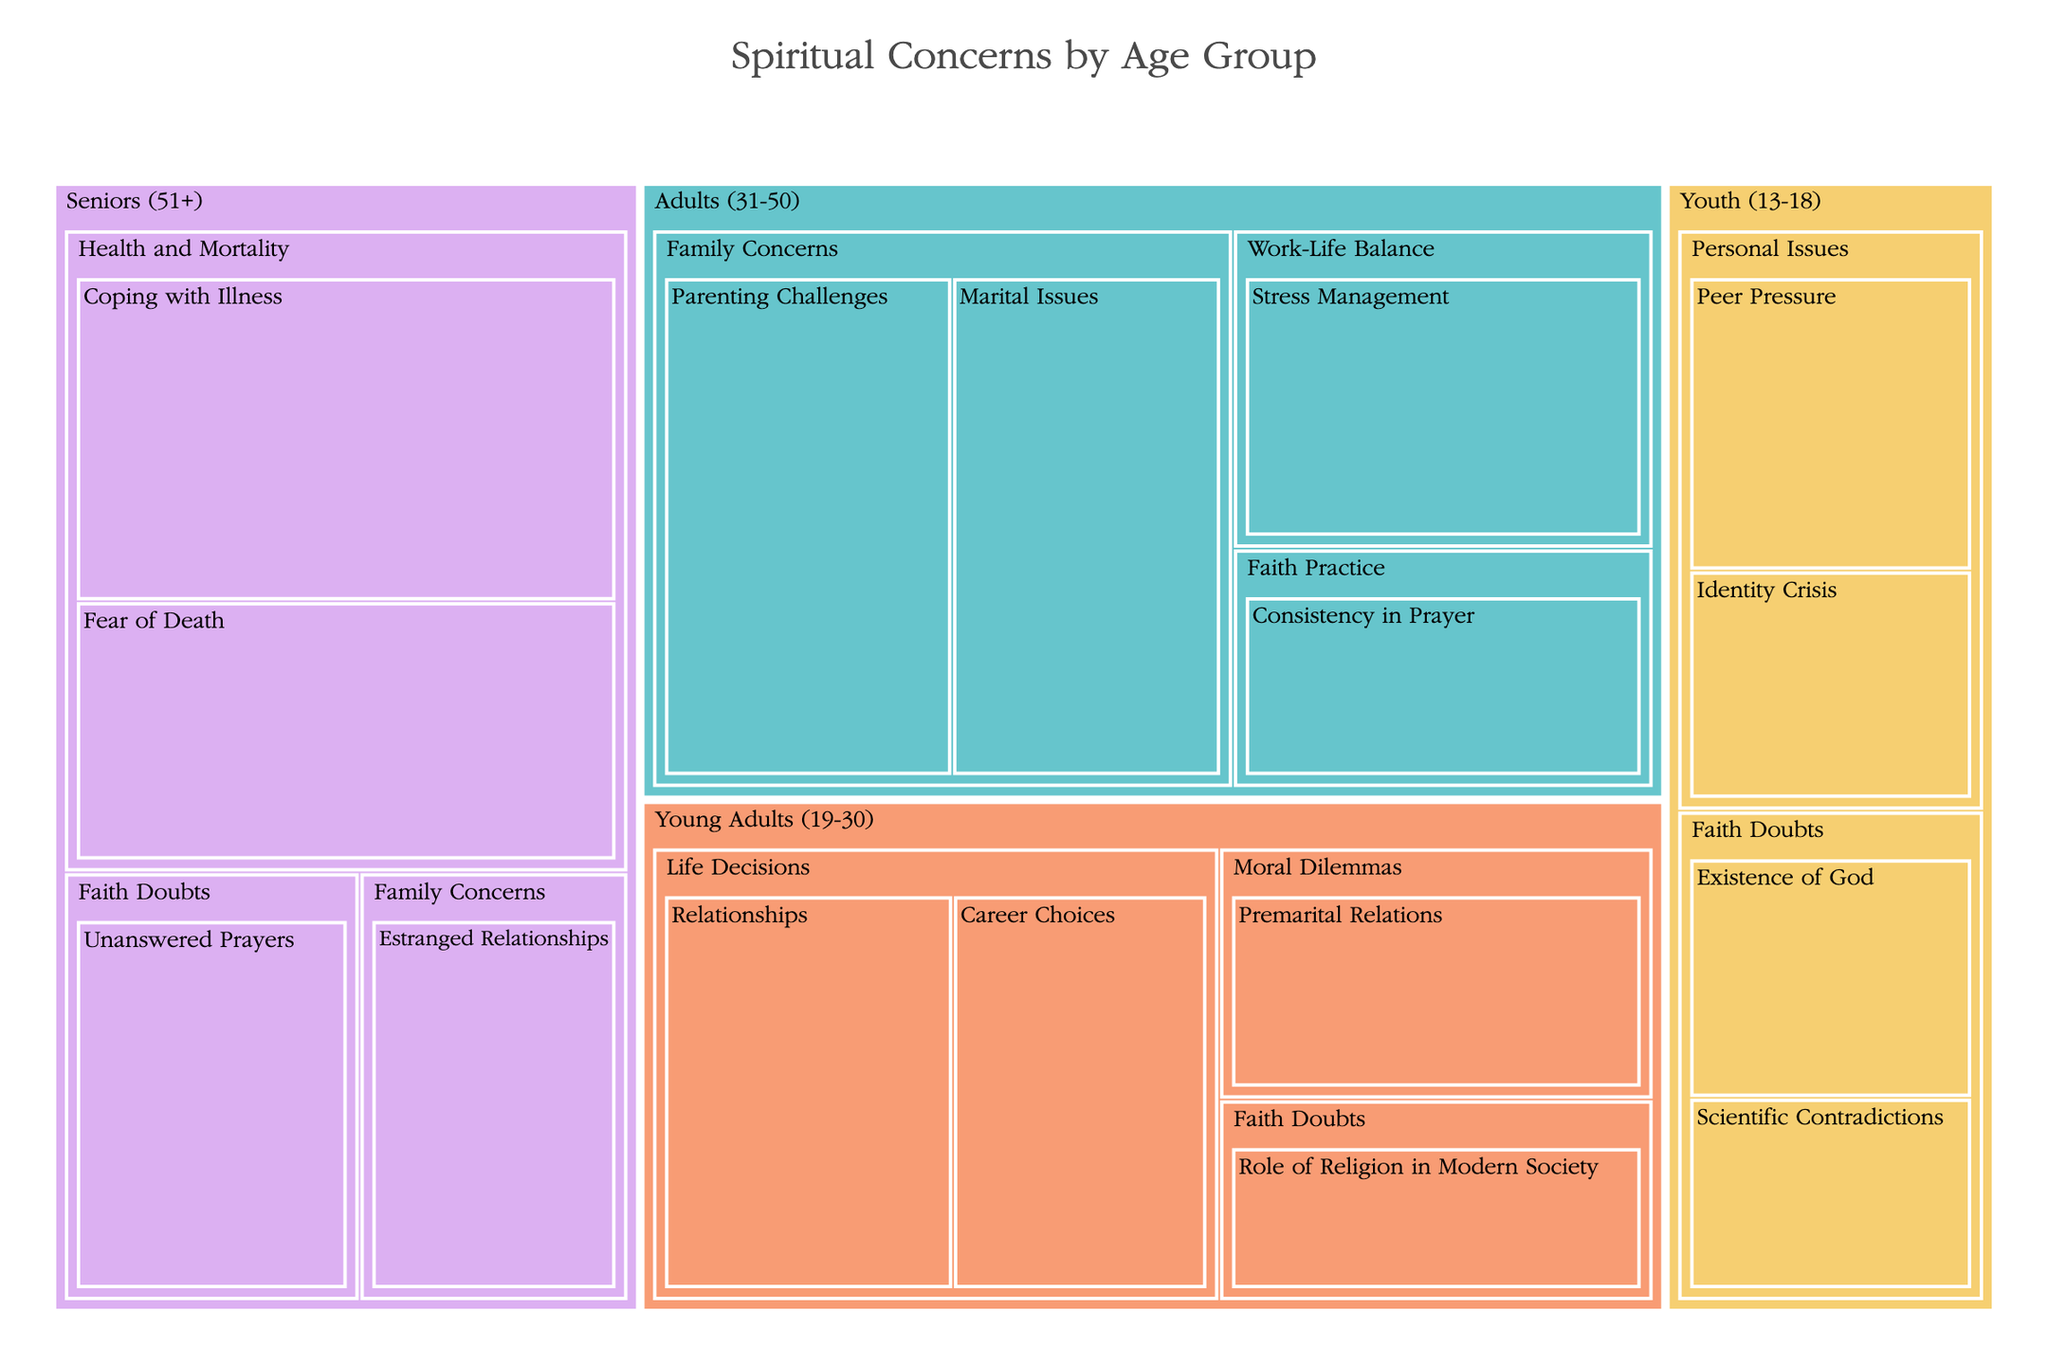What's the highest frequency of a specific concern for the Youth (13-18) age group? Observe the section labeled "Youth (13-18)" and identify the largest box within it. The "Peer Pressure" concern has the highest value with a frequency of 18.
Answer: Peer Pressure, 18 Which age group has the highest frequency concern related to "Health and Mortality"? Locate the "Health and Mortality" concern across different age groups. The "Coping with Illness" box for the Seniors (51+) group shows the highest frequency of 35.
Answer: Seniors (51+), Coping with Illness, 35 What is the total frequency of all concerns in the Adults (31-50) age group? Sum the frequencies of all concerns under the "Adults (31-50)" age group: Parenting Challenges (30), Marital Issues (28), Stress Management (24), and Consistency in Prayer (18). The total is 30 + 28 + 24 + 18 = 100.
Answer: 100 Compare the frequency of "Faith Doubts" concerns between Youth (13-18) and Seniors (51+). Which group has more frequency on this concern, and by how much? "Faith Doubts" concerns for Youth (13-18): Existence of God (15) + Scientific Contradictions (12) = 27. For Seniors (51+): Unanswered Prayers (22). The Youth (13-18) have 5 more concerns (27 - 22 = 5).
Answer: Youth (13-18) by 5 Among the Young Adults (19-30), which specific concern has the second highest frequency? Within "Young Adults (19-30)", identify the top frequencies: Relationships (25) and Career Choices (22). The second highest is "Career Choices" with a frequency of 22.
Answer: Career Choices, 22 Which age group has the most diverse set of concern categories? Check each age group's sections to count the distinct concern categories. The Young Adults (19-30) group has concerns spread across Life Decisions, Faith Doubts, and Moral Dilemmas, totaling 3 categories. No other age group has more categories.
Answer: Young Adults (19-30) What is the combined frequency of "Fear of Death" and "Coping with Illness" concerns for Seniors (51+)? Sum the frequencies of "Fear of Death" (28) and "Coping with Illness" (35). The combined frequency is 28 + 35 = 63.
Answer: 63 